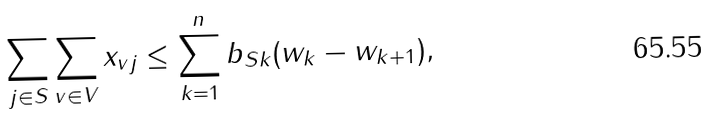<formula> <loc_0><loc_0><loc_500><loc_500>\sum _ { j \in S } \sum _ { v \in V } x _ { v j } \leq \sum _ { k = 1 } ^ { n } b _ { S k } ( w _ { k } - w _ { k + 1 } ) ,</formula> 